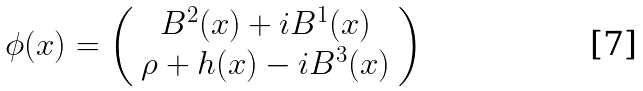Convert formula to latex. <formula><loc_0><loc_0><loc_500><loc_500>\phi ( x ) = \left ( \begin{array} { c } B ^ { 2 } ( x ) + i B ^ { 1 } ( x ) \\ \rho + h ( x ) - i B ^ { 3 } ( x ) \end{array} \right )</formula> 